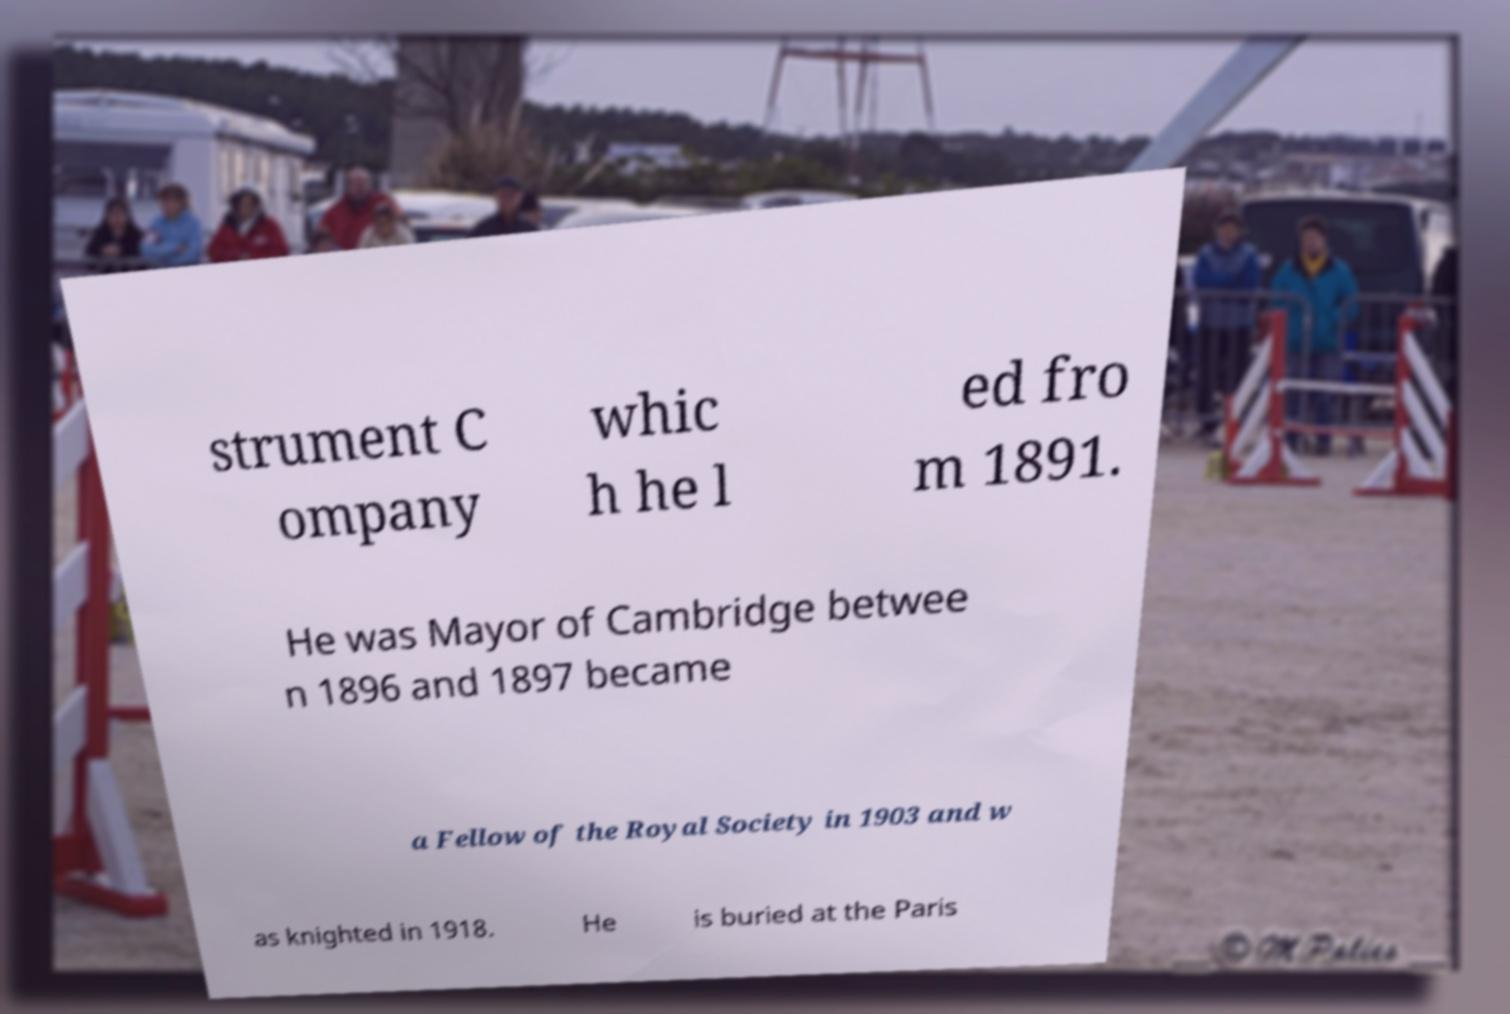For documentation purposes, I need the text within this image transcribed. Could you provide that? strument C ompany whic h he l ed fro m 1891. He was Mayor of Cambridge betwee n 1896 and 1897 became a Fellow of the Royal Society in 1903 and w as knighted in 1918. He is buried at the Paris 